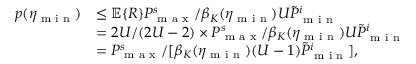Convert formula to latex. <formula><loc_0><loc_0><loc_500><loc_500>\begin{array} { r l } { p ( \eta _ { \min } ) } & { \leq \mathbb { E } \{ R \} P _ { \max } ^ { s } / \beta _ { K } ( \eta _ { \min } ) U \tilde { P } _ { \min } ^ { i } } \\ & { = 2 U / ( 2 U - 2 ) \times P _ { \max } ^ { s } / \beta _ { K } ( \eta _ { \min } ) U \tilde { P } _ { \min } ^ { i } } \\ & { = P _ { \max } ^ { s } / [ \beta _ { K } ( \eta _ { \min } ) ( U - 1 ) \tilde { P } _ { \min } ^ { i } ] , } \end{array}</formula> 